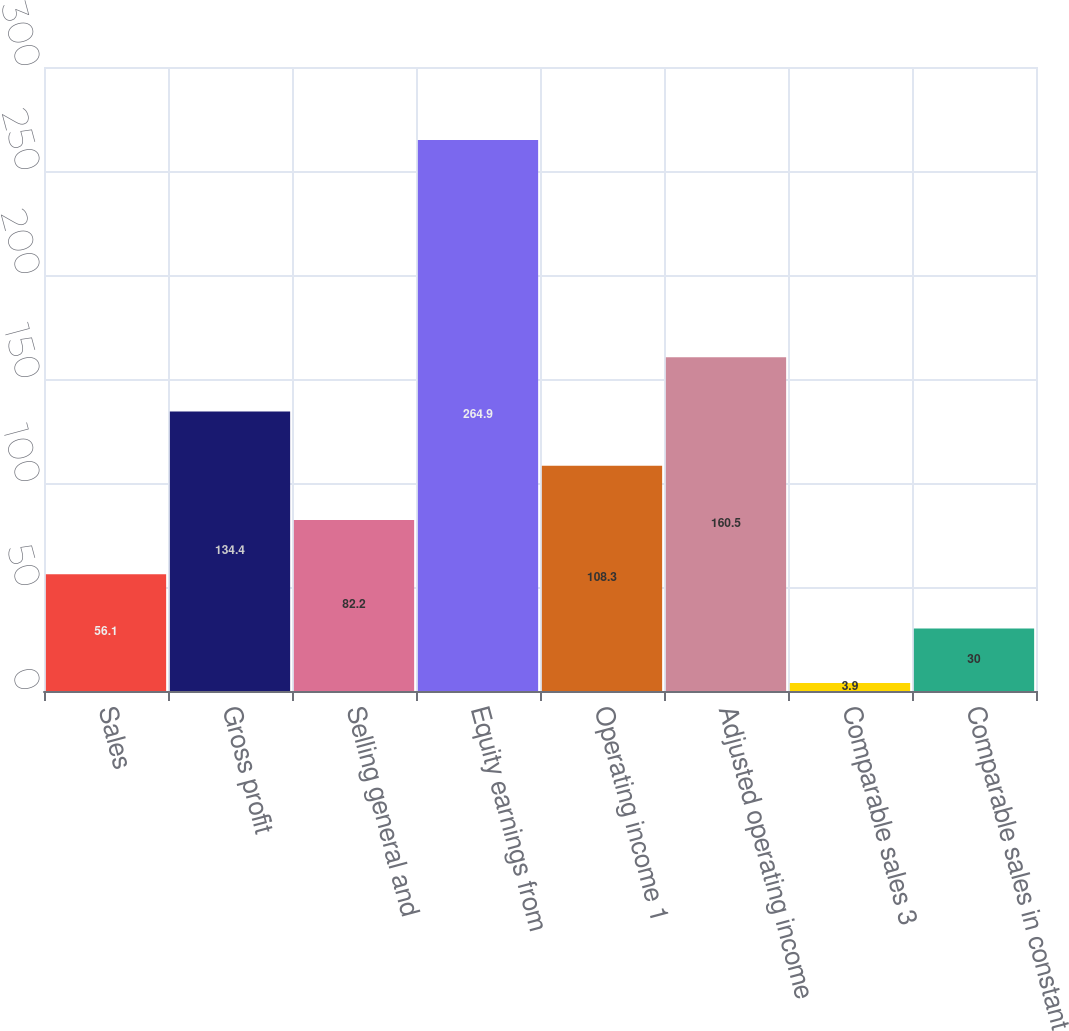<chart> <loc_0><loc_0><loc_500><loc_500><bar_chart><fcel>Sales<fcel>Gross profit<fcel>Selling general and<fcel>Equity earnings from<fcel>Operating income 1<fcel>Adjusted operating income<fcel>Comparable sales 3<fcel>Comparable sales in constant<nl><fcel>56.1<fcel>134.4<fcel>82.2<fcel>264.9<fcel>108.3<fcel>160.5<fcel>3.9<fcel>30<nl></chart> 